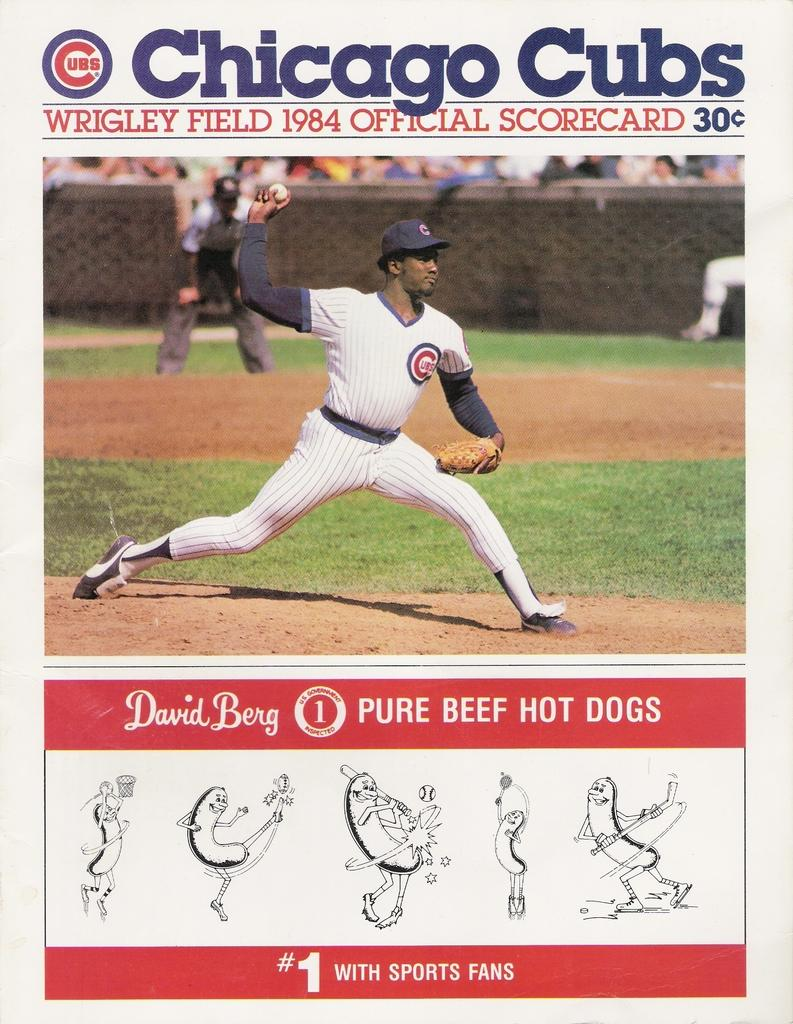<image>
Create a compact narrative representing the image presented. Chicago Cubs David Berg throwing a pitch on the mound 